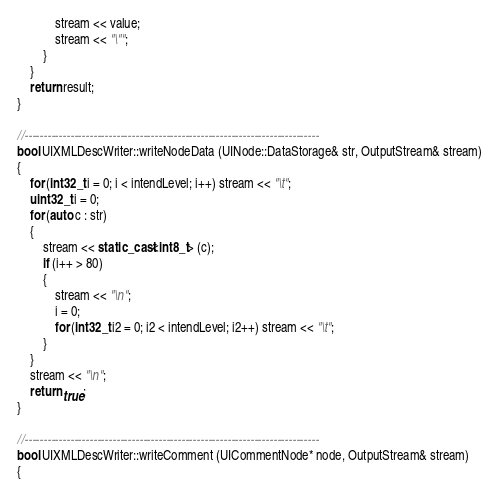<code> <loc_0><loc_0><loc_500><loc_500><_C++_>			stream << value;
			stream << "\"";
		}
	}
	return result;
}

//-----------------------------------------------------------------------------
bool UIXMLDescWriter::writeNodeData (UINode::DataStorage& str, OutputStream& stream)
{
	for (int32_t i = 0; i < intendLevel; i++) stream << "\t";
	uint32_t i = 0;
	for (auto c : str)
	{
		stream << static_cast<int8_t> (c);
		if (i++ > 80)
		{
			stream << "\n";
			i = 0;
			for (int32_t i2 = 0; i2 < intendLevel; i2++) stream << "\t";
		}
	}
	stream << "\n";
	return true;
}

//-----------------------------------------------------------------------------
bool UIXMLDescWriter::writeComment (UICommentNode* node, OutputStream& stream)
{</code> 